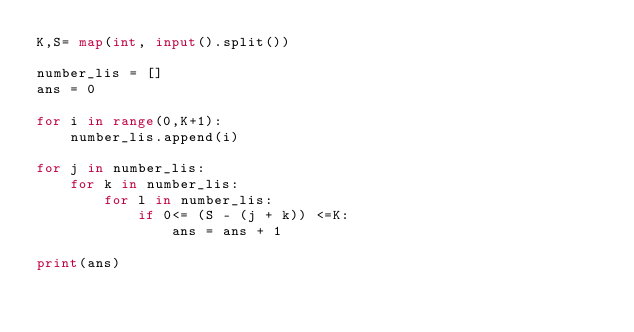Convert code to text. <code><loc_0><loc_0><loc_500><loc_500><_Python_>K,S= map(int, input().split())

number_lis = []
ans = 0

for i in range(0,K+1):
    number_lis.append(i)

for j in number_lis:
    for k in number_lis:
        for l in number_lis:
            if 0<= (S - (j + k)) <=K:
                ans = ans + 1
                
print(ans)
            </code> 